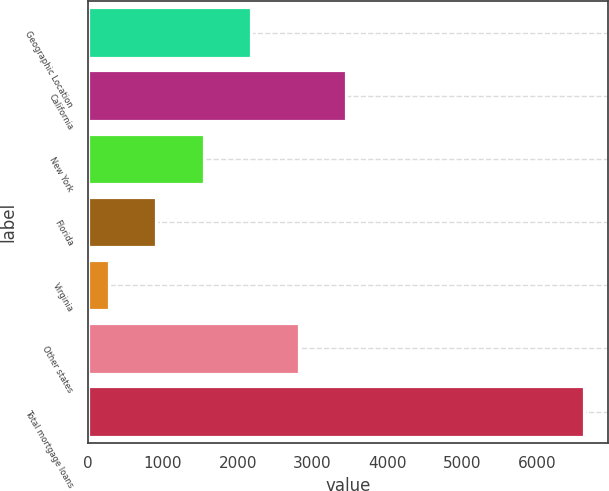<chart> <loc_0><loc_0><loc_500><loc_500><bar_chart><fcel>Geographic Location<fcel>California<fcel>New York<fcel>Florida<fcel>Virginia<fcel>Other states<fcel>Total mortgage loans<nl><fcel>2181.3<fcel>3448.3<fcel>1547.8<fcel>914.3<fcel>280.8<fcel>2814.8<fcel>6615.8<nl></chart> 